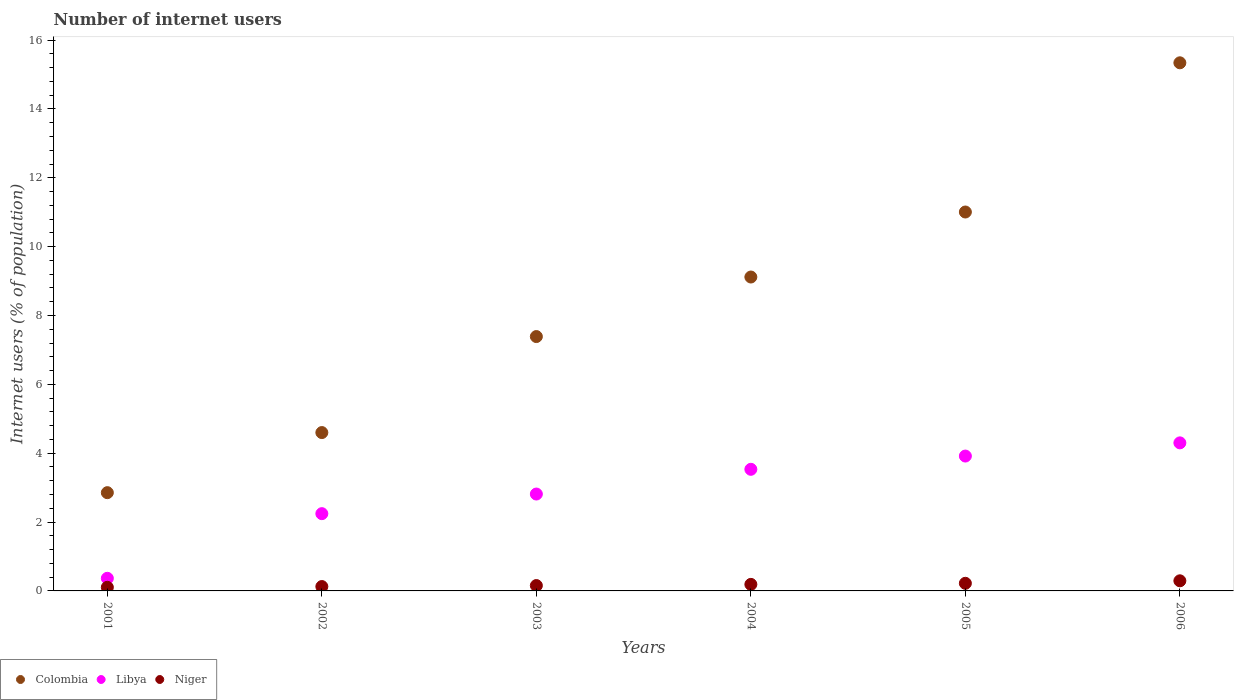How many different coloured dotlines are there?
Ensure brevity in your answer.  3. What is the number of internet users in Niger in 2004?
Provide a short and direct response. 0.19. Across all years, what is the maximum number of internet users in Niger?
Your response must be concise. 0.29. Across all years, what is the minimum number of internet users in Colombia?
Offer a very short reply. 2.85. In which year was the number of internet users in Libya minimum?
Offer a terse response. 2001. What is the total number of internet users in Niger in the graph?
Your response must be concise. 1.09. What is the difference between the number of internet users in Niger in 2002 and that in 2003?
Your answer should be compact. -0.03. What is the difference between the number of internet users in Colombia in 2004 and the number of internet users in Libya in 2005?
Your answer should be very brief. 5.2. What is the average number of internet users in Niger per year?
Your answer should be very brief. 0.18. In the year 2003, what is the difference between the number of internet users in Colombia and number of internet users in Libya?
Give a very brief answer. 4.57. What is the ratio of the number of internet users in Colombia in 2001 to that in 2006?
Offer a terse response. 0.19. Is the number of internet users in Colombia in 2004 less than that in 2005?
Your answer should be very brief. Yes. What is the difference between the highest and the second highest number of internet users in Libya?
Ensure brevity in your answer.  0.38. What is the difference between the highest and the lowest number of internet users in Colombia?
Make the answer very short. 12.49. Is the sum of the number of internet users in Colombia in 2003 and 2006 greater than the maximum number of internet users in Niger across all years?
Your response must be concise. Yes. Is the number of internet users in Libya strictly greater than the number of internet users in Niger over the years?
Your answer should be very brief. Yes. Is the number of internet users in Colombia strictly less than the number of internet users in Libya over the years?
Offer a terse response. No. How many dotlines are there?
Offer a terse response. 3. Are the values on the major ticks of Y-axis written in scientific E-notation?
Provide a succinct answer. No. Does the graph contain any zero values?
Make the answer very short. No. Where does the legend appear in the graph?
Make the answer very short. Bottom left. How are the legend labels stacked?
Provide a succinct answer. Horizontal. What is the title of the graph?
Ensure brevity in your answer.  Number of internet users. Does "East Asia (all income levels)" appear as one of the legend labels in the graph?
Provide a short and direct response. No. What is the label or title of the Y-axis?
Make the answer very short. Internet users (% of population). What is the Internet users (% of population) in Colombia in 2001?
Offer a very short reply. 2.85. What is the Internet users (% of population) of Libya in 2001?
Offer a terse response. 0.37. What is the Internet users (% of population) of Niger in 2001?
Your response must be concise. 0.11. What is the Internet users (% of population) in Colombia in 2002?
Provide a succinct answer. 4.6. What is the Internet users (% of population) of Libya in 2002?
Give a very brief answer. 2.24. What is the Internet users (% of population) of Niger in 2002?
Give a very brief answer. 0.13. What is the Internet users (% of population) in Colombia in 2003?
Keep it short and to the point. 7.39. What is the Internet users (% of population) in Libya in 2003?
Provide a succinct answer. 2.81. What is the Internet users (% of population) in Niger in 2003?
Make the answer very short. 0.16. What is the Internet users (% of population) in Colombia in 2004?
Give a very brief answer. 9.12. What is the Internet users (% of population) of Libya in 2004?
Your answer should be compact. 3.53. What is the Internet users (% of population) of Niger in 2004?
Offer a terse response. 0.19. What is the Internet users (% of population) of Colombia in 2005?
Provide a succinct answer. 11.01. What is the Internet users (% of population) in Libya in 2005?
Provide a short and direct response. 3.92. What is the Internet users (% of population) in Niger in 2005?
Give a very brief answer. 0.22. What is the Internet users (% of population) of Colombia in 2006?
Offer a terse response. 15.34. What is the Internet users (% of population) of Libya in 2006?
Ensure brevity in your answer.  4.3. What is the Internet users (% of population) of Niger in 2006?
Offer a very short reply. 0.29. Across all years, what is the maximum Internet users (% of population) of Colombia?
Make the answer very short. 15.34. Across all years, what is the maximum Internet users (% of population) in Libya?
Your response must be concise. 4.3. Across all years, what is the maximum Internet users (% of population) in Niger?
Offer a very short reply. 0.29. Across all years, what is the minimum Internet users (% of population) of Colombia?
Your answer should be very brief. 2.85. Across all years, what is the minimum Internet users (% of population) of Libya?
Offer a terse response. 0.37. Across all years, what is the minimum Internet users (% of population) of Niger?
Your answer should be compact. 0.11. What is the total Internet users (% of population) in Colombia in the graph?
Keep it short and to the point. 50.31. What is the total Internet users (% of population) of Libya in the graph?
Your response must be concise. 17.18. What is the total Internet users (% of population) in Niger in the graph?
Make the answer very short. 1.09. What is the difference between the Internet users (% of population) of Colombia in 2001 and that in 2002?
Ensure brevity in your answer.  -1.75. What is the difference between the Internet users (% of population) of Libya in 2001 and that in 2002?
Offer a terse response. -1.88. What is the difference between the Internet users (% of population) of Niger in 2001 and that in 2002?
Your response must be concise. -0.02. What is the difference between the Internet users (% of population) in Colombia in 2001 and that in 2003?
Offer a very short reply. -4.53. What is the difference between the Internet users (% of population) of Libya in 2001 and that in 2003?
Provide a short and direct response. -2.45. What is the difference between the Internet users (% of population) of Niger in 2001 and that in 2003?
Keep it short and to the point. -0.05. What is the difference between the Internet users (% of population) in Colombia in 2001 and that in 2004?
Provide a short and direct response. -6.26. What is the difference between the Internet users (% of population) in Libya in 2001 and that in 2004?
Keep it short and to the point. -3.17. What is the difference between the Internet users (% of population) in Niger in 2001 and that in 2004?
Your response must be concise. -0.08. What is the difference between the Internet users (% of population) in Colombia in 2001 and that in 2005?
Make the answer very short. -8.15. What is the difference between the Internet users (% of population) in Libya in 2001 and that in 2005?
Your answer should be compact. -3.55. What is the difference between the Internet users (% of population) of Niger in 2001 and that in 2005?
Give a very brief answer. -0.12. What is the difference between the Internet users (% of population) of Colombia in 2001 and that in 2006?
Make the answer very short. -12.49. What is the difference between the Internet users (% of population) of Libya in 2001 and that in 2006?
Offer a terse response. -3.93. What is the difference between the Internet users (% of population) of Niger in 2001 and that in 2006?
Give a very brief answer. -0.19. What is the difference between the Internet users (% of population) of Colombia in 2002 and that in 2003?
Offer a terse response. -2.79. What is the difference between the Internet users (% of population) of Libya in 2002 and that in 2003?
Ensure brevity in your answer.  -0.57. What is the difference between the Internet users (% of population) of Niger in 2002 and that in 2003?
Ensure brevity in your answer.  -0.03. What is the difference between the Internet users (% of population) in Colombia in 2002 and that in 2004?
Ensure brevity in your answer.  -4.52. What is the difference between the Internet users (% of population) in Libya in 2002 and that in 2004?
Your answer should be very brief. -1.29. What is the difference between the Internet users (% of population) of Niger in 2002 and that in 2004?
Your answer should be very brief. -0.06. What is the difference between the Internet users (% of population) of Colombia in 2002 and that in 2005?
Your answer should be very brief. -6.41. What is the difference between the Internet users (% of population) of Libya in 2002 and that in 2005?
Provide a succinct answer. -1.67. What is the difference between the Internet users (% of population) of Niger in 2002 and that in 2005?
Offer a very short reply. -0.09. What is the difference between the Internet users (% of population) of Colombia in 2002 and that in 2006?
Offer a terse response. -10.74. What is the difference between the Internet users (% of population) in Libya in 2002 and that in 2006?
Give a very brief answer. -2.06. What is the difference between the Internet users (% of population) of Niger in 2002 and that in 2006?
Keep it short and to the point. -0.17. What is the difference between the Internet users (% of population) in Colombia in 2003 and that in 2004?
Offer a terse response. -1.73. What is the difference between the Internet users (% of population) in Libya in 2003 and that in 2004?
Give a very brief answer. -0.72. What is the difference between the Internet users (% of population) of Niger in 2003 and that in 2004?
Offer a terse response. -0.03. What is the difference between the Internet users (% of population) in Colombia in 2003 and that in 2005?
Provide a short and direct response. -3.62. What is the difference between the Internet users (% of population) in Libya in 2003 and that in 2005?
Give a very brief answer. -1.1. What is the difference between the Internet users (% of population) of Niger in 2003 and that in 2005?
Keep it short and to the point. -0.07. What is the difference between the Internet users (% of population) in Colombia in 2003 and that in 2006?
Offer a very short reply. -7.95. What is the difference between the Internet users (% of population) of Libya in 2003 and that in 2006?
Your answer should be very brief. -1.49. What is the difference between the Internet users (% of population) of Niger in 2003 and that in 2006?
Ensure brevity in your answer.  -0.14. What is the difference between the Internet users (% of population) in Colombia in 2004 and that in 2005?
Offer a terse response. -1.89. What is the difference between the Internet users (% of population) of Libya in 2004 and that in 2005?
Keep it short and to the point. -0.38. What is the difference between the Internet users (% of population) of Niger in 2004 and that in 2005?
Keep it short and to the point. -0.03. What is the difference between the Internet users (% of population) of Colombia in 2004 and that in 2006?
Provide a short and direct response. -6.22. What is the difference between the Internet users (% of population) in Libya in 2004 and that in 2006?
Your answer should be compact. -0.77. What is the difference between the Internet users (% of population) in Niger in 2004 and that in 2006?
Offer a terse response. -0.1. What is the difference between the Internet users (% of population) in Colombia in 2005 and that in 2006?
Keep it short and to the point. -4.33. What is the difference between the Internet users (% of population) in Libya in 2005 and that in 2006?
Your response must be concise. -0.38. What is the difference between the Internet users (% of population) of Niger in 2005 and that in 2006?
Keep it short and to the point. -0.07. What is the difference between the Internet users (% of population) in Colombia in 2001 and the Internet users (% of population) in Libya in 2002?
Your answer should be compact. 0.61. What is the difference between the Internet users (% of population) in Colombia in 2001 and the Internet users (% of population) in Niger in 2002?
Offer a very short reply. 2.73. What is the difference between the Internet users (% of population) of Libya in 2001 and the Internet users (% of population) of Niger in 2002?
Make the answer very short. 0.24. What is the difference between the Internet users (% of population) in Colombia in 2001 and the Internet users (% of population) in Libya in 2003?
Make the answer very short. 0.04. What is the difference between the Internet users (% of population) in Colombia in 2001 and the Internet users (% of population) in Niger in 2003?
Provide a short and direct response. 2.7. What is the difference between the Internet users (% of population) in Libya in 2001 and the Internet users (% of population) in Niger in 2003?
Ensure brevity in your answer.  0.21. What is the difference between the Internet users (% of population) in Colombia in 2001 and the Internet users (% of population) in Libya in 2004?
Your response must be concise. -0.68. What is the difference between the Internet users (% of population) in Colombia in 2001 and the Internet users (% of population) in Niger in 2004?
Offer a terse response. 2.66. What is the difference between the Internet users (% of population) in Libya in 2001 and the Internet users (% of population) in Niger in 2004?
Offer a terse response. 0.18. What is the difference between the Internet users (% of population) in Colombia in 2001 and the Internet users (% of population) in Libya in 2005?
Make the answer very short. -1.06. What is the difference between the Internet users (% of population) in Colombia in 2001 and the Internet users (% of population) in Niger in 2005?
Offer a terse response. 2.63. What is the difference between the Internet users (% of population) of Libya in 2001 and the Internet users (% of population) of Niger in 2005?
Your answer should be very brief. 0.15. What is the difference between the Internet users (% of population) of Colombia in 2001 and the Internet users (% of population) of Libya in 2006?
Make the answer very short. -1.45. What is the difference between the Internet users (% of population) of Colombia in 2001 and the Internet users (% of population) of Niger in 2006?
Your answer should be compact. 2.56. What is the difference between the Internet users (% of population) of Libya in 2001 and the Internet users (% of population) of Niger in 2006?
Provide a succinct answer. 0.07. What is the difference between the Internet users (% of population) in Colombia in 2002 and the Internet users (% of population) in Libya in 2003?
Give a very brief answer. 1.79. What is the difference between the Internet users (% of population) of Colombia in 2002 and the Internet users (% of population) of Niger in 2003?
Your answer should be very brief. 4.44. What is the difference between the Internet users (% of population) of Libya in 2002 and the Internet users (% of population) of Niger in 2003?
Offer a very short reply. 2.09. What is the difference between the Internet users (% of population) of Colombia in 2002 and the Internet users (% of population) of Libya in 2004?
Ensure brevity in your answer.  1.07. What is the difference between the Internet users (% of population) in Colombia in 2002 and the Internet users (% of population) in Niger in 2004?
Provide a succinct answer. 4.41. What is the difference between the Internet users (% of population) of Libya in 2002 and the Internet users (% of population) of Niger in 2004?
Your answer should be compact. 2.05. What is the difference between the Internet users (% of population) in Colombia in 2002 and the Internet users (% of population) in Libya in 2005?
Your answer should be compact. 0.68. What is the difference between the Internet users (% of population) in Colombia in 2002 and the Internet users (% of population) in Niger in 2005?
Your answer should be compact. 4.38. What is the difference between the Internet users (% of population) of Libya in 2002 and the Internet users (% of population) of Niger in 2005?
Provide a succinct answer. 2.02. What is the difference between the Internet users (% of population) in Colombia in 2002 and the Internet users (% of population) in Libya in 2006?
Offer a terse response. 0.3. What is the difference between the Internet users (% of population) in Colombia in 2002 and the Internet users (% of population) in Niger in 2006?
Make the answer very short. 4.31. What is the difference between the Internet users (% of population) in Libya in 2002 and the Internet users (% of population) in Niger in 2006?
Give a very brief answer. 1.95. What is the difference between the Internet users (% of population) of Colombia in 2003 and the Internet users (% of population) of Libya in 2004?
Provide a succinct answer. 3.86. What is the difference between the Internet users (% of population) in Colombia in 2003 and the Internet users (% of population) in Niger in 2004?
Your response must be concise. 7.2. What is the difference between the Internet users (% of population) in Libya in 2003 and the Internet users (% of population) in Niger in 2004?
Offer a terse response. 2.62. What is the difference between the Internet users (% of population) in Colombia in 2003 and the Internet users (% of population) in Libya in 2005?
Your answer should be very brief. 3.47. What is the difference between the Internet users (% of population) in Colombia in 2003 and the Internet users (% of population) in Niger in 2005?
Provide a short and direct response. 7.17. What is the difference between the Internet users (% of population) of Libya in 2003 and the Internet users (% of population) of Niger in 2005?
Provide a succinct answer. 2.59. What is the difference between the Internet users (% of population) in Colombia in 2003 and the Internet users (% of population) in Libya in 2006?
Provide a short and direct response. 3.09. What is the difference between the Internet users (% of population) in Colombia in 2003 and the Internet users (% of population) in Niger in 2006?
Provide a succinct answer. 7.09. What is the difference between the Internet users (% of population) of Libya in 2003 and the Internet users (% of population) of Niger in 2006?
Offer a very short reply. 2.52. What is the difference between the Internet users (% of population) in Colombia in 2004 and the Internet users (% of population) in Libya in 2005?
Your answer should be very brief. 5.2. What is the difference between the Internet users (% of population) in Colombia in 2004 and the Internet users (% of population) in Niger in 2005?
Your answer should be compact. 8.9. What is the difference between the Internet users (% of population) of Libya in 2004 and the Internet users (% of population) of Niger in 2005?
Your response must be concise. 3.31. What is the difference between the Internet users (% of population) of Colombia in 2004 and the Internet users (% of population) of Libya in 2006?
Offer a very short reply. 4.82. What is the difference between the Internet users (% of population) of Colombia in 2004 and the Internet users (% of population) of Niger in 2006?
Provide a succinct answer. 8.82. What is the difference between the Internet users (% of population) in Libya in 2004 and the Internet users (% of population) in Niger in 2006?
Your response must be concise. 3.24. What is the difference between the Internet users (% of population) of Colombia in 2005 and the Internet users (% of population) of Libya in 2006?
Give a very brief answer. 6.71. What is the difference between the Internet users (% of population) of Colombia in 2005 and the Internet users (% of population) of Niger in 2006?
Your answer should be compact. 10.71. What is the difference between the Internet users (% of population) of Libya in 2005 and the Internet users (% of population) of Niger in 2006?
Keep it short and to the point. 3.62. What is the average Internet users (% of population) in Colombia per year?
Your answer should be compact. 8.39. What is the average Internet users (% of population) in Libya per year?
Make the answer very short. 2.86. What is the average Internet users (% of population) in Niger per year?
Give a very brief answer. 0.18. In the year 2001, what is the difference between the Internet users (% of population) in Colombia and Internet users (% of population) in Libya?
Make the answer very short. 2.49. In the year 2001, what is the difference between the Internet users (% of population) in Colombia and Internet users (% of population) in Niger?
Your answer should be very brief. 2.75. In the year 2001, what is the difference between the Internet users (% of population) in Libya and Internet users (% of population) in Niger?
Provide a short and direct response. 0.26. In the year 2002, what is the difference between the Internet users (% of population) of Colombia and Internet users (% of population) of Libya?
Provide a short and direct response. 2.36. In the year 2002, what is the difference between the Internet users (% of population) in Colombia and Internet users (% of population) in Niger?
Your response must be concise. 4.47. In the year 2002, what is the difference between the Internet users (% of population) in Libya and Internet users (% of population) in Niger?
Your response must be concise. 2.12. In the year 2003, what is the difference between the Internet users (% of population) in Colombia and Internet users (% of population) in Libya?
Your answer should be compact. 4.57. In the year 2003, what is the difference between the Internet users (% of population) in Colombia and Internet users (% of population) in Niger?
Your answer should be very brief. 7.23. In the year 2003, what is the difference between the Internet users (% of population) in Libya and Internet users (% of population) in Niger?
Offer a terse response. 2.66. In the year 2004, what is the difference between the Internet users (% of population) in Colombia and Internet users (% of population) in Libya?
Give a very brief answer. 5.59. In the year 2004, what is the difference between the Internet users (% of population) in Colombia and Internet users (% of population) in Niger?
Make the answer very short. 8.93. In the year 2004, what is the difference between the Internet users (% of population) of Libya and Internet users (% of population) of Niger?
Make the answer very short. 3.34. In the year 2005, what is the difference between the Internet users (% of population) of Colombia and Internet users (% of population) of Libya?
Your response must be concise. 7.09. In the year 2005, what is the difference between the Internet users (% of population) in Colombia and Internet users (% of population) in Niger?
Offer a very short reply. 10.79. In the year 2005, what is the difference between the Internet users (% of population) in Libya and Internet users (% of population) in Niger?
Your answer should be very brief. 3.7. In the year 2006, what is the difference between the Internet users (% of population) of Colombia and Internet users (% of population) of Libya?
Provide a short and direct response. 11.04. In the year 2006, what is the difference between the Internet users (% of population) in Colombia and Internet users (% of population) in Niger?
Ensure brevity in your answer.  15.05. In the year 2006, what is the difference between the Internet users (% of population) in Libya and Internet users (% of population) in Niger?
Offer a terse response. 4.01. What is the ratio of the Internet users (% of population) in Colombia in 2001 to that in 2002?
Give a very brief answer. 0.62. What is the ratio of the Internet users (% of population) in Libya in 2001 to that in 2002?
Provide a succinct answer. 0.16. What is the ratio of the Internet users (% of population) in Niger in 2001 to that in 2002?
Keep it short and to the point. 0.83. What is the ratio of the Internet users (% of population) in Colombia in 2001 to that in 2003?
Make the answer very short. 0.39. What is the ratio of the Internet users (% of population) in Libya in 2001 to that in 2003?
Offer a terse response. 0.13. What is the ratio of the Internet users (% of population) of Niger in 2001 to that in 2003?
Give a very brief answer. 0.68. What is the ratio of the Internet users (% of population) in Colombia in 2001 to that in 2004?
Provide a succinct answer. 0.31. What is the ratio of the Internet users (% of population) in Libya in 2001 to that in 2004?
Your answer should be compact. 0.1. What is the ratio of the Internet users (% of population) of Niger in 2001 to that in 2004?
Offer a terse response. 0.55. What is the ratio of the Internet users (% of population) in Colombia in 2001 to that in 2005?
Make the answer very short. 0.26. What is the ratio of the Internet users (% of population) in Libya in 2001 to that in 2005?
Offer a terse response. 0.09. What is the ratio of the Internet users (% of population) of Niger in 2001 to that in 2005?
Keep it short and to the point. 0.48. What is the ratio of the Internet users (% of population) of Colombia in 2001 to that in 2006?
Make the answer very short. 0.19. What is the ratio of the Internet users (% of population) in Libya in 2001 to that in 2006?
Your response must be concise. 0.09. What is the ratio of the Internet users (% of population) of Niger in 2001 to that in 2006?
Ensure brevity in your answer.  0.36. What is the ratio of the Internet users (% of population) in Colombia in 2002 to that in 2003?
Keep it short and to the point. 0.62. What is the ratio of the Internet users (% of population) in Libya in 2002 to that in 2003?
Offer a terse response. 0.8. What is the ratio of the Internet users (% of population) of Niger in 2002 to that in 2003?
Your answer should be very brief. 0.82. What is the ratio of the Internet users (% of population) in Colombia in 2002 to that in 2004?
Provide a short and direct response. 0.5. What is the ratio of the Internet users (% of population) in Libya in 2002 to that in 2004?
Give a very brief answer. 0.64. What is the ratio of the Internet users (% of population) of Niger in 2002 to that in 2004?
Make the answer very short. 0.67. What is the ratio of the Internet users (% of population) in Colombia in 2002 to that in 2005?
Make the answer very short. 0.42. What is the ratio of the Internet users (% of population) of Libya in 2002 to that in 2005?
Provide a succinct answer. 0.57. What is the ratio of the Internet users (% of population) in Niger in 2002 to that in 2005?
Offer a very short reply. 0.57. What is the ratio of the Internet users (% of population) in Colombia in 2002 to that in 2006?
Your answer should be very brief. 0.3. What is the ratio of the Internet users (% of population) in Libya in 2002 to that in 2006?
Your answer should be very brief. 0.52. What is the ratio of the Internet users (% of population) in Niger in 2002 to that in 2006?
Offer a terse response. 0.43. What is the ratio of the Internet users (% of population) in Colombia in 2003 to that in 2004?
Ensure brevity in your answer.  0.81. What is the ratio of the Internet users (% of population) of Libya in 2003 to that in 2004?
Make the answer very short. 0.8. What is the ratio of the Internet users (% of population) in Niger in 2003 to that in 2004?
Offer a very short reply. 0.82. What is the ratio of the Internet users (% of population) in Colombia in 2003 to that in 2005?
Your answer should be very brief. 0.67. What is the ratio of the Internet users (% of population) of Libya in 2003 to that in 2005?
Offer a very short reply. 0.72. What is the ratio of the Internet users (% of population) in Niger in 2003 to that in 2005?
Your answer should be compact. 0.7. What is the ratio of the Internet users (% of population) of Colombia in 2003 to that in 2006?
Your answer should be very brief. 0.48. What is the ratio of the Internet users (% of population) of Libya in 2003 to that in 2006?
Provide a succinct answer. 0.65. What is the ratio of the Internet users (% of population) in Niger in 2003 to that in 2006?
Offer a terse response. 0.53. What is the ratio of the Internet users (% of population) of Colombia in 2004 to that in 2005?
Make the answer very short. 0.83. What is the ratio of the Internet users (% of population) in Libya in 2004 to that in 2005?
Ensure brevity in your answer.  0.9. What is the ratio of the Internet users (% of population) in Niger in 2004 to that in 2005?
Your response must be concise. 0.86. What is the ratio of the Internet users (% of population) in Colombia in 2004 to that in 2006?
Give a very brief answer. 0.59. What is the ratio of the Internet users (% of population) in Libya in 2004 to that in 2006?
Provide a short and direct response. 0.82. What is the ratio of the Internet users (% of population) of Niger in 2004 to that in 2006?
Give a very brief answer. 0.65. What is the ratio of the Internet users (% of population) of Colombia in 2005 to that in 2006?
Ensure brevity in your answer.  0.72. What is the ratio of the Internet users (% of population) in Libya in 2005 to that in 2006?
Offer a terse response. 0.91. What is the ratio of the Internet users (% of population) in Niger in 2005 to that in 2006?
Offer a very short reply. 0.75. What is the difference between the highest and the second highest Internet users (% of population) in Colombia?
Your answer should be compact. 4.33. What is the difference between the highest and the second highest Internet users (% of population) in Libya?
Make the answer very short. 0.38. What is the difference between the highest and the second highest Internet users (% of population) of Niger?
Provide a short and direct response. 0.07. What is the difference between the highest and the lowest Internet users (% of population) of Colombia?
Your answer should be very brief. 12.49. What is the difference between the highest and the lowest Internet users (% of population) in Libya?
Make the answer very short. 3.93. What is the difference between the highest and the lowest Internet users (% of population) of Niger?
Offer a very short reply. 0.19. 